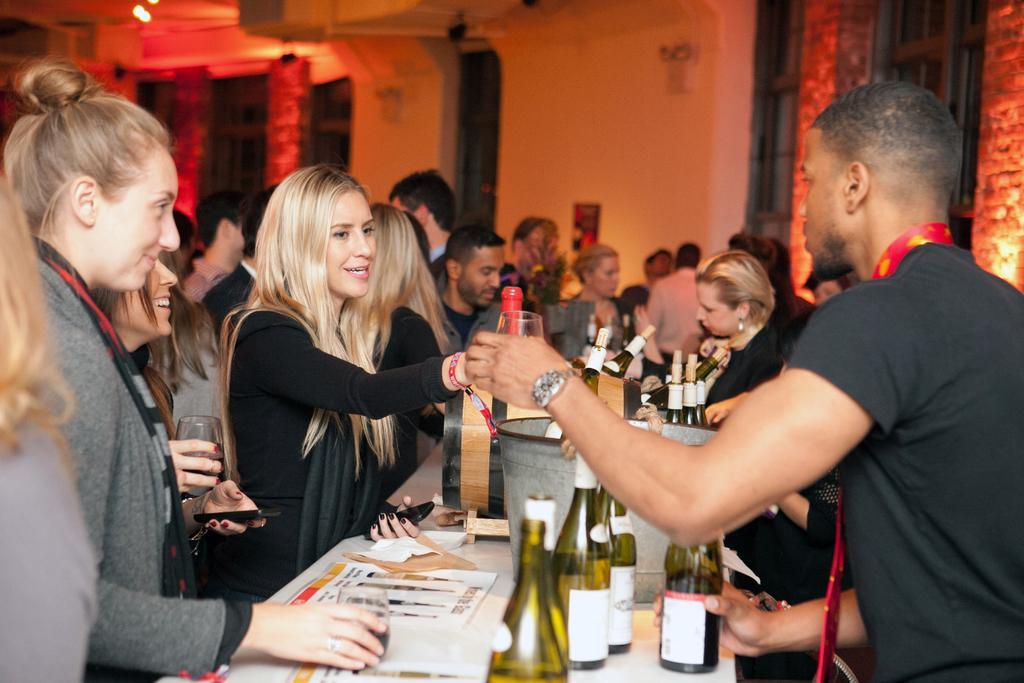How would you summarize this image in a sentence or two? This image is taken indoors. In the background there is a wall. There are few windows. At the top of the image there is a roof. In the middle of the image many people are standing and a few are holding glasses in their hands. A few are holding bottles in their hands. At the bottom of the image there is a table with many bottles, papers and many objects on it. 